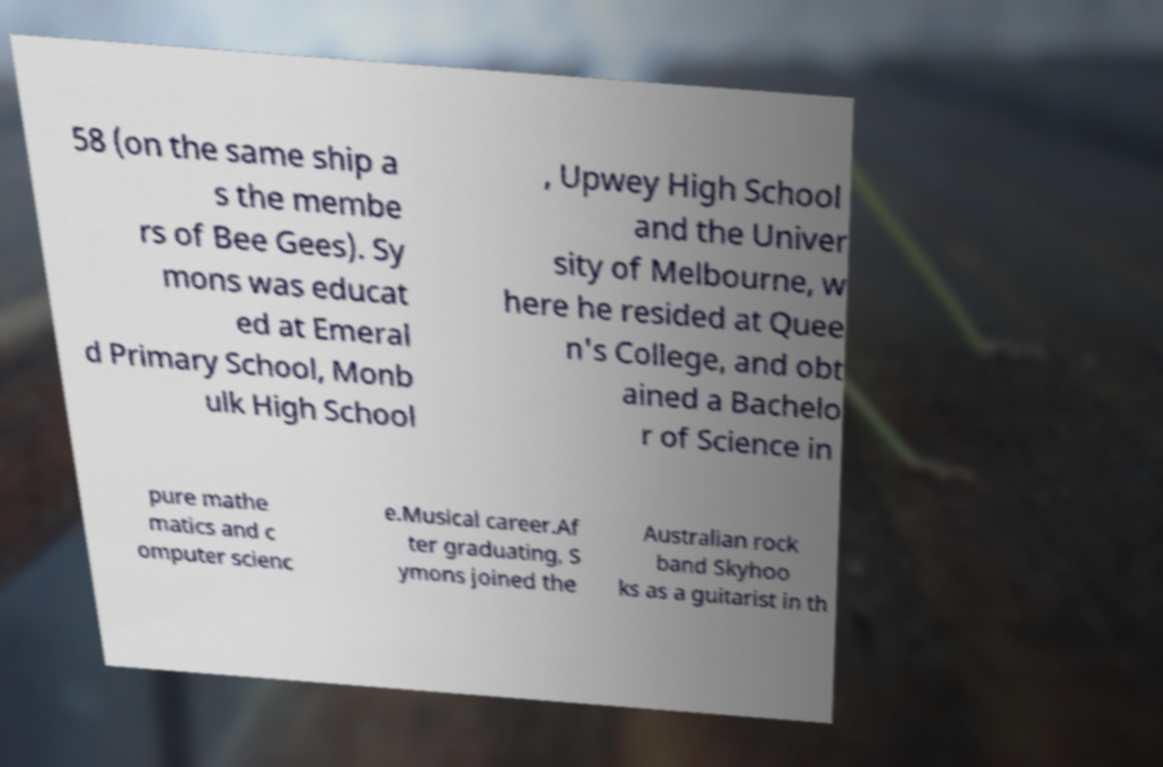Can you read and provide the text displayed in the image?This photo seems to have some interesting text. Can you extract and type it out for me? 58 (on the same ship a s the membe rs of Bee Gees). Sy mons was educat ed at Emeral d Primary School, Monb ulk High School , Upwey High School and the Univer sity of Melbourne, w here he resided at Quee n's College, and obt ained a Bachelo r of Science in pure mathe matics and c omputer scienc e.Musical career.Af ter graduating, S ymons joined the Australian rock band Skyhoo ks as a guitarist in th 